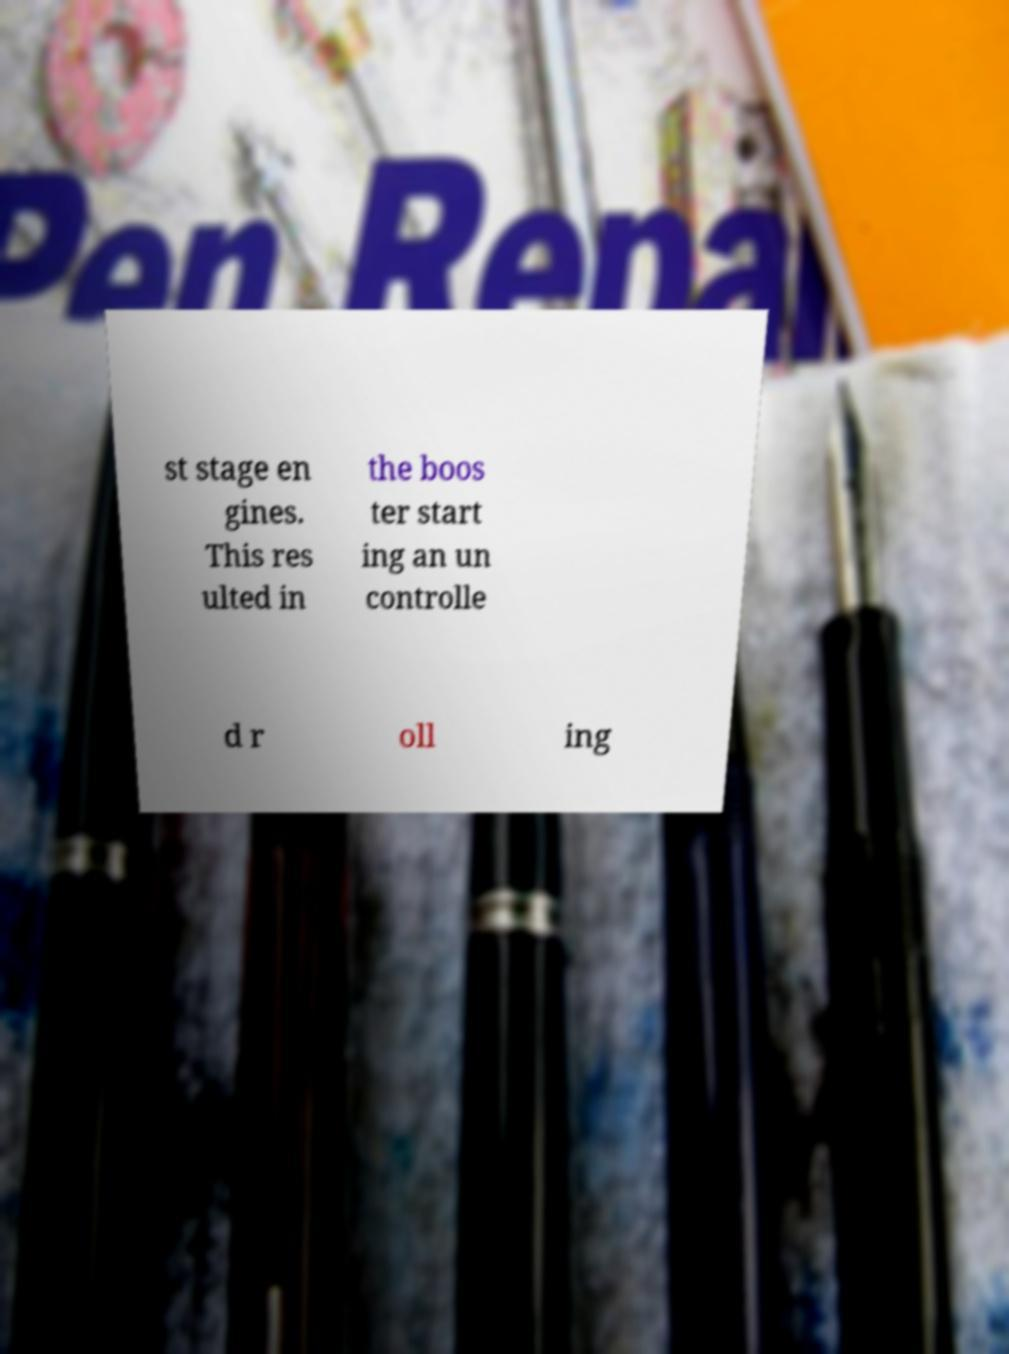For documentation purposes, I need the text within this image transcribed. Could you provide that? st stage en gines. This res ulted in the boos ter start ing an un controlle d r oll ing 